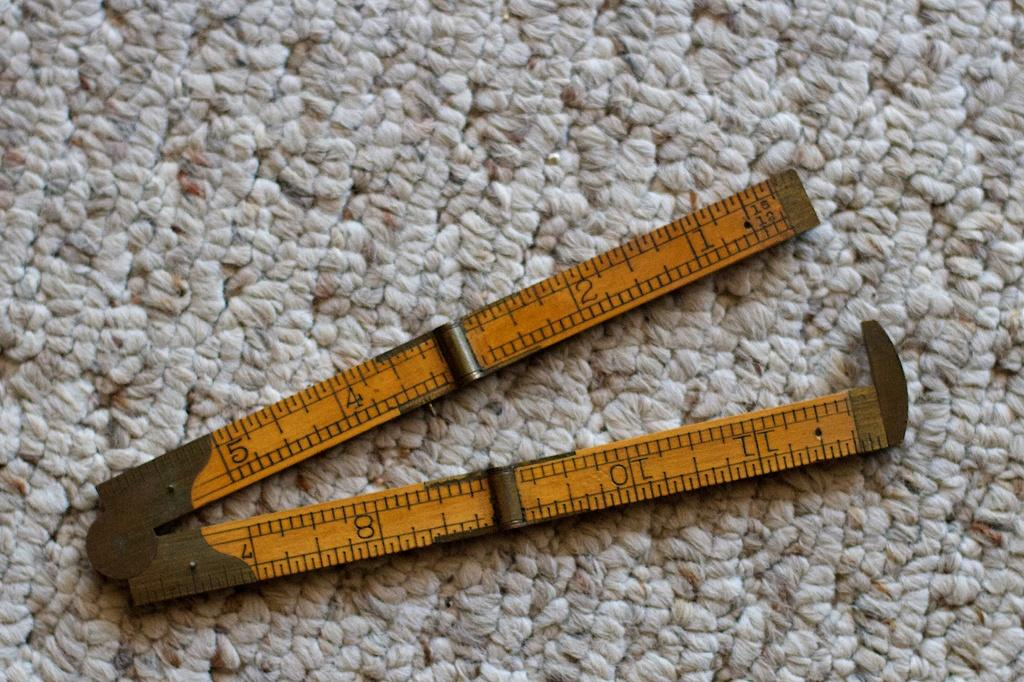Provide a one-sentence caption for the provided image. On white and beige carpet a pocket sized ruler, measuring 12 inches, can be seen folded almost in half. 